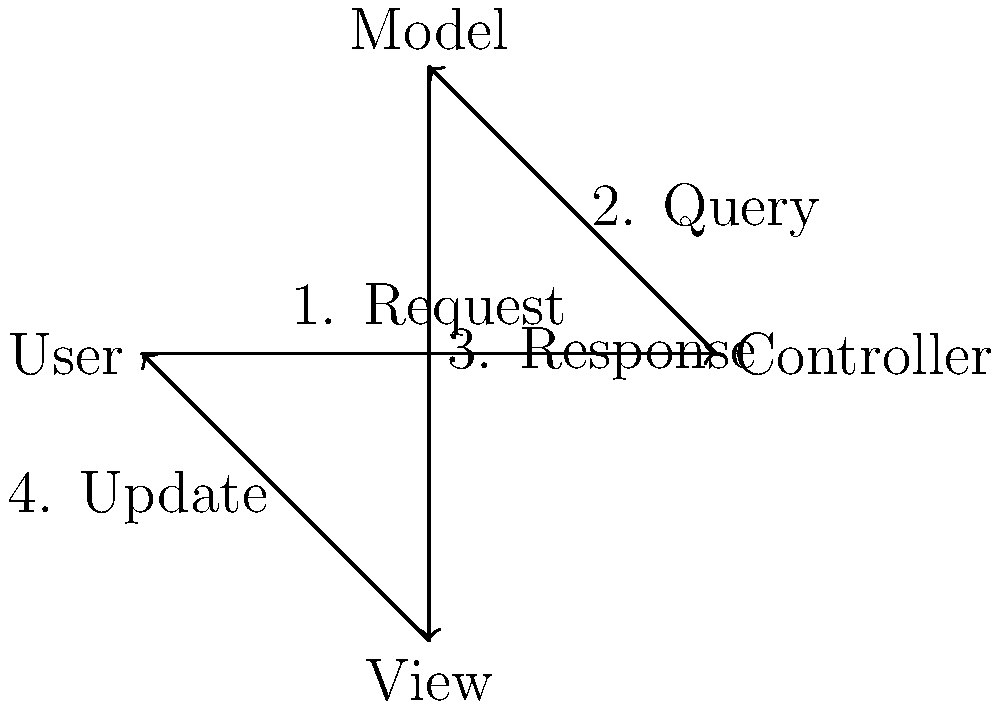In the MVC architecture flow diagram shown above, which component is responsible for handling user input and determining the appropriate action to take? To answer this question, let's break down the MVC (Model-View-Controller) architecture flow:

1. The diagram shows four components: User, Controller, Model, and View.

2. The flow starts with the User sending a request (step 1) to the Controller.

3. The Controller then queries the Model (step 2) for data or to update the data.

4. The Model responds (step 3) to the View with the requested data or confirmation of the update.

5. Finally, the View updates (step 4) what the User sees.

In this flow, the Controller is the component that receives the initial request from the User. It's responsible for interpreting this input and deciding what action should be taken. This could involve querying the Model for data, updating the Model with new information, or instructing the View to update its display.

The Controller acts as an intermediary between the User's input and the Model's data, making it the component responsible for handling user input and determining the appropriate action.
Answer: Controller 